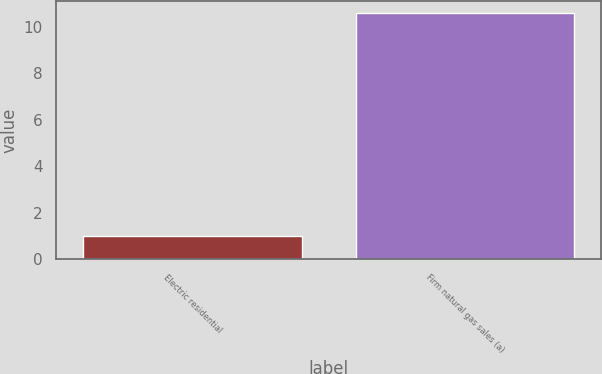Convert chart. <chart><loc_0><loc_0><loc_500><loc_500><bar_chart><fcel>Electric residential<fcel>Firm natural gas sales (a)<nl><fcel>1<fcel>10.6<nl></chart> 